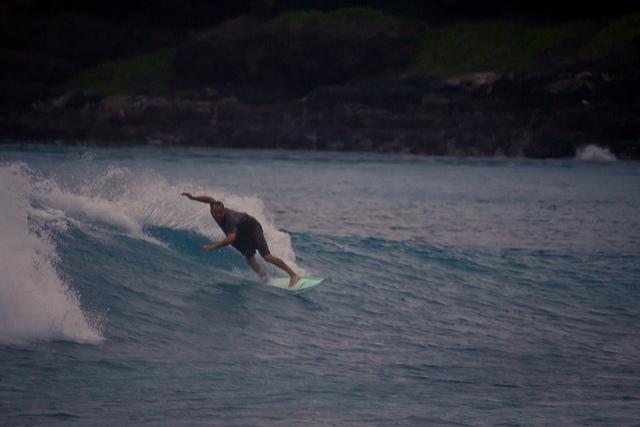Are these people in the mountains?
Be succinct. No. What is it called when water forms this kind of rolling shape?
Write a very short answer. Wave. Is somebody about to fall?
Write a very short answer. No. Is this man in the process of falling off of the surfboard?
Quick response, please. No. Is the surfer riding a wave?
Be succinct. Yes. 